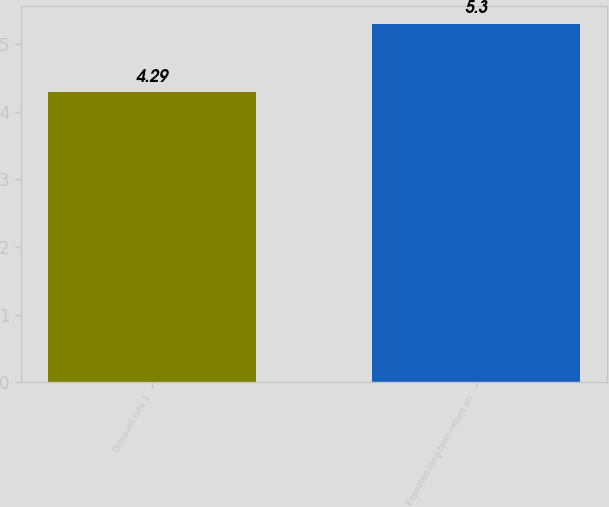Convert chart to OTSL. <chart><loc_0><loc_0><loc_500><loc_500><bar_chart><fcel>Discount rate 1<fcel>Expected long-term return on<nl><fcel>4.29<fcel>5.3<nl></chart> 